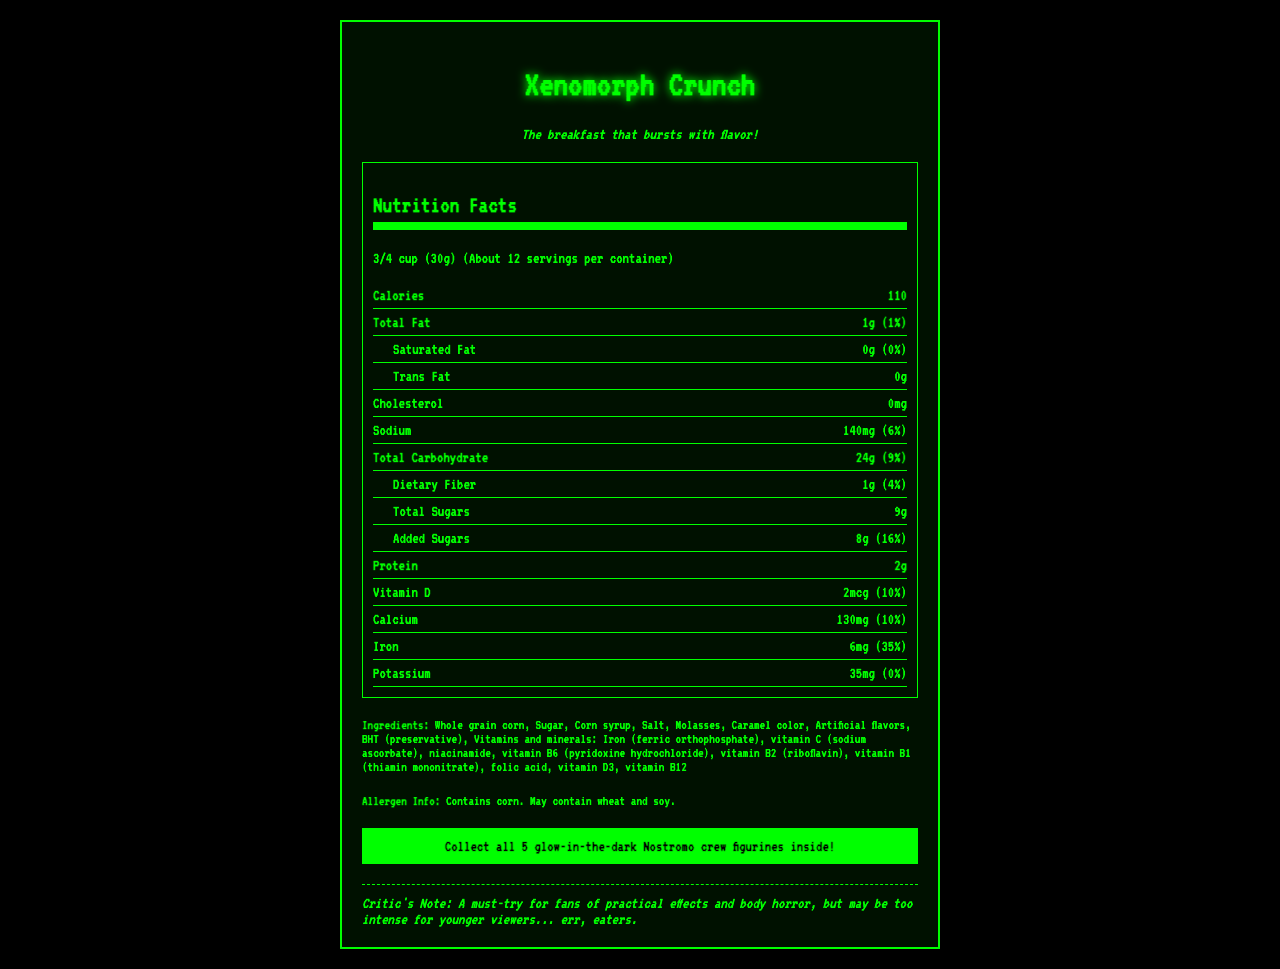what is the serving size of Xenomorph Crunch? The serving size information is clearly labeled at the top of the nutrition facts section.
Answer: 3/4 cup (30g) how many calories are in one serving of Xenomorph Crunch? The calories per serving are explicitly mentioned under the nutrition facts.
Answer: 110 how much sodium does one serving contain? The sodium content per serving is listed in the nutrition facts section.
Answer: 140mg what is the percentage daily value of iron in one serving? The percentage daily value of iron is mentioned in the nutrition facts section.
Answer: 35% what allergens are mentioned in the document? The allergen information is specified near the ingredients list.
Answer: Contains corn. May contain wheat and soy. how many servings are there per container? A. About 10 B. About 12 C. About 15 D. About 20 The number of servings per container is given at the top of the nutrition facts section.
Answer: B. About 12 what is the amount of added sugars in one serving? A. 6g B. 8g C. 10g D. 12g The amount of added sugars is listed in the nutrition facts section.
Answer: B. 8g is there any cholesterol in Xenomorph Crunch? The cholesterol amount is explicitly mentioned as 0mg in the nutrition facts.
Answer: No does this cereal contain Vitamin D? The presence of Vitamin D and its amount are listed in the nutrition facts.
Answer: Yes summarize the main idea of the document. The document provides detailed nutrition information, ingredient list, allergen info, promotional text, and cultural references.
Answer: Xenomorph Crunch is a retro-themed cereal inspired by the cult classic sci-fi horror movie "Alien." The cereal's packaging and promotional items cater to the nostalgia factor. The nutrition facts highlight the calorie count, fat, carbohydrates, and vitamins. It includes allergen information and promotion for glow-in-the-dark figurines. what is the amount of protein in one serving? The protein content is listed in the nutrition facts section.
Answer: 2g which company manufactures Xenomorph Crunch? The manufacturer's name is listed in the document.
Answer: Weyland-Yutani Foods, Inc. how much dietary fiber is in one serving? The amount of dietary fiber is specified in the nutrition facts.
Answer: 1g does the cereal contain any molasses? Molasses is listed among the ingredients.
Answer: Yes what is the tagline for Xenomorph Crunch? The tagline is provided in a distinguished section of the document.
Answer: The breakfast that bursts with flavor! why might this cereal be too intense for younger eaters? The critic's note implies that the cereal's thematic elements might be intense for younger audiences.
Answer: Due to its inspiration from the horror classic 'Alien' combined with practical effects and body horror themes. is the exact percentage of daily value of potassium provided? The document states "0%" for the potassium daily value, which is not a specific percentage.
Answer: No Which vitamin has a daily value of 10% per serving? A. Vitamin D B. Calcium C. Iron D. Both A and B Both Vitamin D and Calcium have a daily value of 10% per serving as specified in the nutrition facts.
Answer: D. Both A and B what is the caramel color's role in the cereal? The document does not describe the detailed role of caramel color, only listing it as an ingredient.
Answer: Not clearly specified 